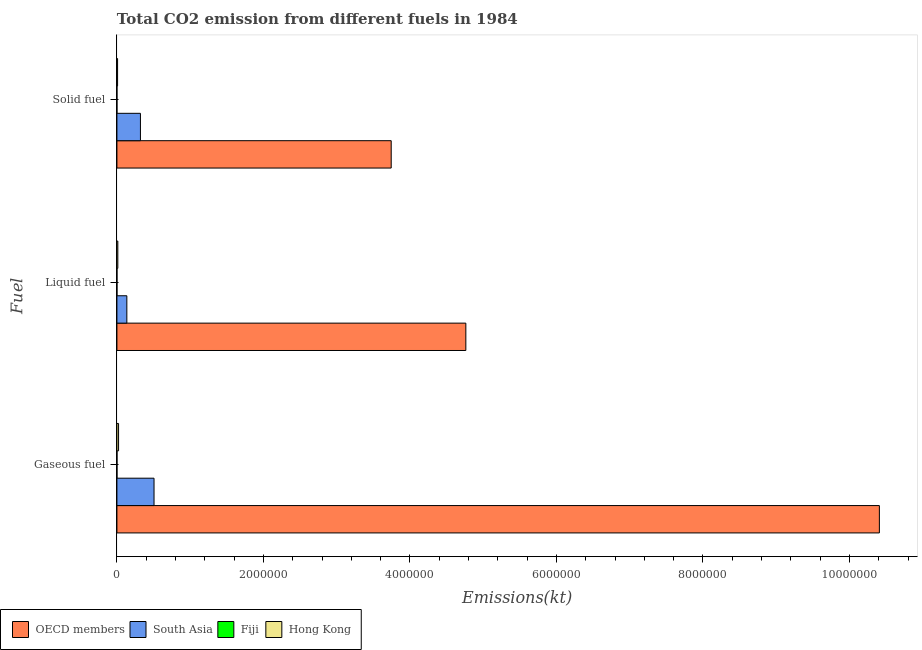How many bars are there on the 2nd tick from the bottom?
Keep it short and to the point. 4. What is the label of the 1st group of bars from the top?
Provide a succinct answer. Solid fuel. What is the amount of co2 emissions from solid fuel in OECD members?
Keep it short and to the point. 3.74e+06. Across all countries, what is the maximum amount of co2 emissions from solid fuel?
Your answer should be compact. 3.74e+06. Across all countries, what is the minimum amount of co2 emissions from gaseous fuel?
Keep it short and to the point. 583.05. In which country was the amount of co2 emissions from gaseous fuel maximum?
Make the answer very short. OECD members. In which country was the amount of co2 emissions from solid fuel minimum?
Provide a short and direct response. Fiji. What is the total amount of co2 emissions from gaseous fuel in the graph?
Make the answer very short. 1.09e+07. What is the difference between the amount of co2 emissions from liquid fuel in OECD members and that in Hong Kong?
Provide a succinct answer. 4.75e+06. What is the difference between the amount of co2 emissions from liquid fuel in South Asia and the amount of co2 emissions from gaseous fuel in OECD members?
Give a very brief answer. -1.03e+07. What is the average amount of co2 emissions from gaseous fuel per country?
Your response must be concise. 2.73e+06. What is the difference between the amount of co2 emissions from gaseous fuel and amount of co2 emissions from solid fuel in Fiji?
Give a very brief answer. 524.38. In how many countries, is the amount of co2 emissions from liquid fuel greater than 8000000 kt?
Provide a succinct answer. 0. What is the ratio of the amount of co2 emissions from solid fuel in South Asia to that in Fiji?
Keep it short and to the point. 5471.05. What is the difference between the highest and the second highest amount of co2 emissions from gaseous fuel?
Your answer should be compact. 9.90e+06. What is the difference between the highest and the lowest amount of co2 emissions from gaseous fuel?
Offer a very short reply. 1.04e+07. What does the 1st bar from the top in Solid fuel represents?
Provide a succinct answer. Hong Kong. Is it the case that in every country, the sum of the amount of co2 emissions from gaseous fuel and amount of co2 emissions from liquid fuel is greater than the amount of co2 emissions from solid fuel?
Your answer should be very brief. Yes. How many bars are there?
Offer a very short reply. 12. Are all the bars in the graph horizontal?
Your response must be concise. Yes. Are the values on the major ticks of X-axis written in scientific E-notation?
Keep it short and to the point. No. Where does the legend appear in the graph?
Your answer should be very brief. Bottom left. How many legend labels are there?
Make the answer very short. 4. How are the legend labels stacked?
Your answer should be very brief. Horizontal. What is the title of the graph?
Provide a short and direct response. Total CO2 emission from different fuels in 1984. Does "Bhutan" appear as one of the legend labels in the graph?
Ensure brevity in your answer.  No. What is the label or title of the X-axis?
Ensure brevity in your answer.  Emissions(kt). What is the label or title of the Y-axis?
Your response must be concise. Fuel. What is the Emissions(kt) of OECD members in Gaseous fuel?
Provide a short and direct response. 1.04e+07. What is the Emissions(kt) in South Asia in Gaseous fuel?
Offer a very short reply. 5.07e+05. What is the Emissions(kt) in Fiji in Gaseous fuel?
Your answer should be very brief. 583.05. What is the Emissions(kt) in Hong Kong in Gaseous fuel?
Ensure brevity in your answer.  2.23e+04. What is the Emissions(kt) in OECD members in Liquid fuel?
Offer a very short reply. 4.76e+06. What is the Emissions(kt) of South Asia in Liquid fuel?
Offer a terse response. 1.35e+05. What is the Emissions(kt) of Fiji in Liquid fuel?
Provide a succinct answer. 476.71. What is the Emissions(kt) in Hong Kong in Liquid fuel?
Offer a terse response. 1.24e+04. What is the Emissions(kt) in OECD members in Solid fuel?
Your response must be concise. 3.74e+06. What is the Emissions(kt) in South Asia in Solid fuel?
Provide a succinct answer. 3.21e+05. What is the Emissions(kt) of Fiji in Solid fuel?
Make the answer very short. 58.67. What is the Emissions(kt) of Hong Kong in Solid fuel?
Provide a succinct answer. 9061.16. Across all Fuel, what is the maximum Emissions(kt) of OECD members?
Provide a short and direct response. 1.04e+07. Across all Fuel, what is the maximum Emissions(kt) in South Asia?
Your answer should be compact. 5.07e+05. Across all Fuel, what is the maximum Emissions(kt) of Fiji?
Offer a very short reply. 583.05. Across all Fuel, what is the maximum Emissions(kt) in Hong Kong?
Your response must be concise. 2.23e+04. Across all Fuel, what is the minimum Emissions(kt) in OECD members?
Offer a terse response. 3.74e+06. Across all Fuel, what is the minimum Emissions(kt) of South Asia?
Your response must be concise. 1.35e+05. Across all Fuel, what is the minimum Emissions(kt) of Fiji?
Offer a very short reply. 58.67. Across all Fuel, what is the minimum Emissions(kt) in Hong Kong?
Offer a very short reply. 9061.16. What is the total Emissions(kt) in OECD members in the graph?
Keep it short and to the point. 1.89e+07. What is the total Emissions(kt) of South Asia in the graph?
Ensure brevity in your answer.  9.63e+05. What is the total Emissions(kt) of Fiji in the graph?
Provide a succinct answer. 1118.43. What is the total Emissions(kt) in Hong Kong in the graph?
Your answer should be compact. 4.38e+04. What is the difference between the Emissions(kt) in OECD members in Gaseous fuel and that in Liquid fuel?
Your answer should be very brief. 5.65e+06. What is the difference between the Emissions(kt) of South Asia in Gaseous fuel and that in Liquid fuel?
Make the answer very short. 3.71e+05. What is the difference between the Emissions(kt) in Fiji in Gaseous fuel and that in Liquid fuel?
Keep it short and to the point. 106.34. What is the difference between the Emissions(kt) in Hong Kong in Gaseous fuel and that in Liquid fuel?
Make the answer very short. 9981.57. What is the difference between the Emissions(kt) in OECD members in Gaseous fuel and that in Solid fuel?
Your response must be concise. 6.66e+06. What is the difference between the Emissions(kt) in South Asia in Gaseous fuel and that in Solid fuel?
Provide a short and direct response. 1.86e+05. What is the difference between the Emissions(kt) of Fiji in Gaseous fuel and that in Solid fuel?
Your answer should be compact. 524.38. What is the difference between the Emissions(kt) of Hong Kong in Gaseous fuel and that in Solid fuel?
Ensure brevity in your answer.  1.33e+04. What is the difference between the Emissions(kt) of OECD members in Liquid fuel and that in Solid fuel?
Your answer should be very brief. 1.02e+06. What is the difference between the Emissions(kt) of South Asia in Liquid fuel and that in Solid fuel?
Keep it short and to the point. -1.86e+05. What is the difference between the Emissions(kt) of Fiji in Liquid fuel and that in Solid fuel?
Give a very brief answer. 418.04. What is the difference between the Emissions(kt) in Hong Kong in Liquid fuel and that in Solid fuel?
Ensure brevity in your answer.  3303.97. What is the difference between the Emissions(kt) of OECD members in Gaseous fuel and the Emissions(kt) of South Asia in Liquid fuel?
Offer a very short reply. 1.03e+07. What is the difference between the Emissions(kt) in OECD members in Gaseous fuel and the Emissions(kt) in Fiji in Liquid fuel?
Provide a succinct answer. 1.04e+07. What is the difference between the Emissions(kt) in OECD members in Gaseous fuel and the Emissions(kt) in Hong Kong in Liquid fuel?
Keep it short and to the point. 1.04e+07. What is the difference between the Emissions(kt) of South Asia in Gaseous fuel and the Emissions(kt) of Fiji in Liquid fuel?
Give a very brief answer. 5.06e+05. What is the difference between the Emissions(kt) in South Asia in Gaseous fuel and the Emissions(kt) in Hong Kong in Liquid fuel?
Provide a succinct answer. 4.94e+05. What is the difference between the Emissions(kt) of Fiji in Gaseous fuel and the Emissions(kt) of Hong Kong in Liquid fuel?
Keep it short and to the point. -1.18e+04. What is the difference between the Emissions(kt) in OECD members in Gaseous fuel and the Emissions(kt) in South Asia in Solid fuel?
Ensure brevity in your answer.  1.01e+07. What is the difference between the Emissions(kt) of OECD members in Gaseous fuel and the Emissions(kt) of Fiji in Solid fuel?
Give a very brief answer. 1.04e+07. What is the difference between the Emissions(kt) in OECD members in Gaseous fuel and the Emissions(kt) in Hong Kong in Solid fuel?
Provide a short and direct response. 1.04e+07. What is the difference between the Emissions(kt) of South Asia in Gaseous fuel and the Emissions(kt) of Fiji in Solid fuel?
Give a very brief answer. 5.07e+05. What is the difference between the Emissions(kt) in South Asia in Gaseous fuel and the Emissions(kt) in Hong Kong in Solid fuel?
Offer a very short reply. 4.98e+05. What is the difference between the Emissions(kt) in Fiji in Gaseous fuel and the Emissions(kt) in Hong Kong in Solid fuel?
Your answer should be very brief. -8478.1. What is the difference between the Emissions(kt) of OECD members in Liquid fuel and the Emissions(kt) of South Asia in Solid fuel?
Your answer should be compact. 4.44e+06. What is the difference between the Emissions(kt) of OECD members in Liquid fuel and the Emissions(kt) of Fiji in Solid fuel?
Ensure brevity in your answer.  4.76e+06. What is the difference between the Emissions(kt) in OECD members in Liquid fuel and the Emissions(kt) in Hong Kong in Solid fuel?
Provide a succinct answer. 4.75e+06. What is the difference between the Emissions(kt) in South Asia in Liquid fuel and the Emissions(kt) in Fiji in Solid fuel?
Give a very brief answer. 1.35e+05. What is the difference between the Emissions(kt) of South Asia in Liquid fuel and the Emissions(kt) of Hong Kong in Solid fuel?
Provide a succinct answer. 1.26e+05. What is the difference between the Emissions(kt) of Fiji in Liquid fuel and the Emissions(kt) of Hong Kong in Solid fuel?
Your answer should be very brief. -8584.45. What is the average Emissions(kt) in OECD members per Fuel?
Offer a very short reply. 6.31e+06. What is the average Emissions(kt) in South Asia per Fuel?
Offer a terse response. 3.21e+05. What is the average Emissions(kt) of Fiji per Fuel?
Keep it short and to the point. 372.81. What is the average Emissions(kt) in Hong Kong per Fuel?
Keep it short and to the point. 1.46e+04. What is the difference between the Emissions(kt) of OECD members and Emissions(kt) of South Asia in Gaseous fuel?
Ensure brevity in your answer.  9.90e+06. What is the difference between the Emissions(kt) in OECD members and Emissions(kt) in Fiji in Gaseous fuel?
Offer a very short reply. 1.04e+07. What is the difference between the Emissions(kt) in OECD members and Emissions(kt) in Hong Kong in Gaseous fuel?
Your answer should be compact. 1.04e+07. What is the difference between the Emissions(kt) of South Asia and Emissions(kt) of Fiji in Gaseous fuel?
Your answer should be very brief. 5.06e+05. What is the difference between the Emissions(kt) in South Asia and Emissions(kt) in Hong Kong in Gaseous fuel?
Your response must be concise. 4.84e+05. What is the difference between the Emissions(kt) in Fiji and Emissions(kt) in Hong Kong in Gaseous fuel?
Offer a terse response. -2.18e+04. What is the difference between the Emissions(kt) in OECD members and Emissions(kt) in South Asia in Liquid fuel?
Offer a terse response. 4.63e+06. What is the difference between the Emissions(kt) in OECD members and Emissions(kt) in Fiji in Liquid fuel?
Make the answer very short. 4.76e+06. What is the difference between the Emissions(kt) of OECD members and Emissions(kt) of Hong Kong in Liquid fuel?
Your answer should be compact. 4.75e+06. What is the difference between the Emissions(kt) of South Asia and Emissions(kt) of Fiji in Liquid fuel?
Offer a very short reply. 1.35e+05. What is the difference between the Emissions(kt) in South Asia and Emissions(kt) in Hong Kong in Liquid fuel?
Give a very brief answer. 1.23e+05. What is the difference between the Emissions(kt) in Fiji and Emissions(kt) in Hong Kong in Liquid fuel?
Provide a short and direct response. -1.19e+04. What is the difference between the Emissions(kt) in OECD members and Emissions(kt) in South Asia in Solid fuel?
Your answer should be compact. 3.42e+06. What is the difference between the Emissions(kt) in OECD members and Emissions(kt) in Fiji in Solid fuel?
Make the answer very short. 3.74e+06. What is the difference between the Emissions(kt) of OECD members and Emissions(kt) of Hong Kong in Solid fuel?
Your answer should be compact. 3.74e+06. What is the difference between the Emissions(kt) in South Asia and Emissions(kt) in Fiji in Solid fuel?
Offer a very short reply. 3.21e+05. What is the difference between the Emissions(kt) of South Asia and Emissions(kt) of Hong Kong in Solid fuel?
Give a very brief answer. 3.12e+05. What is the difference between the Emissions(kt) of Fiji and Emissions(kt) of Hong Kong in Solid fuel?
Provide a short and direct response. -9002.49. What is the ratio of the Emissions(kt) in OECD members in Gaseous fuel to that in Liquid fuel?
Your answer should be very brief. 2.19. What is the ratio of the Emissions(kt) of South Asia in Gaseous fuel to that in Liquid fuel?
Make the answer very short. 3.74. What is the ratio of the Emissions(kt) of Fiji in Gaseous fuel to that in Liquid fuel?
Offer a terse response. 1.22. What is the ratio of the Emissions(kt) in Hong Kong in Gaseous fuel to that in Liquid fuel?
Give a very brief answer. 1.81. What is the ratio of the Emissions(kt) in OECD members in Gaseous fuel to that in Solid fuel?
Offer a very short reply. 2.78. What is the ratio of the Emissions(kt) of South Asia in Gaseous fuel to that in Solid fuel?
Your answer should be compact. 1.58. What is the ratio of the Emissions(kt) of Fiji in Gaseous fuel to that in Solid fuel?
Provide a succinct answer. 9.94. What is the ratio of the Emissions(kt) of Hong Kong in Gaseous fuel to that in Solid fuel?
Your answer should be very brief. 2.47. What is the ratio of the Emissions(kt) in OECD members in Liquid fuel to that in Solid fuel?
Keep it short and to the point. 1.27. What is the ratio of the Emissions(kt) of South Asia in Liquid fuel to that in Solid fuel?
Keep it short and to the point. 0.42. What is the ratio of the Emissions(kt) in Fiji in Liquid fuel to that in Solid fuel?
Keep it short and to the point. 8.12. What is the ratio of the Emissions(kt) of Hong Kong in Liquid fuel to that in Solid fuel?
Provide a short and direct response. 1.36. What is the difference between the highest and the second highest Emissions(kt) of OECD members?
Provide a short and direct response. 5.65e+06. What is the difference between the highest and the second highest Emissions(kt) in South Asia?
Your answer should be compact. 1.86e+05. What is the difference between the highest and the second highest Emissions(kt) in Fiji?
Keep it short and to the point. 106.34. What is the difference between the highest and the second highest Emissions(kt) in Hong Kong?
Provide a succinct answer. 9981.57. What is the difference between the highest and the lowest Emissions(kt) of OECD members?
Ensure brevity in your answer.  6.66e+06. What is the difference between the highest and the lowest Emissions(kt) of South Asia?
Give a very brief answer. 3.71e+05. What is the difference between the highest and the lowest Emissions(kt) of Fiji?
Provide a short and direct response. 524.38. What is the difference between the highest and the lowest Emissions(kt) of Hong Kong?
Offer a terse response. 1.33e+04. 